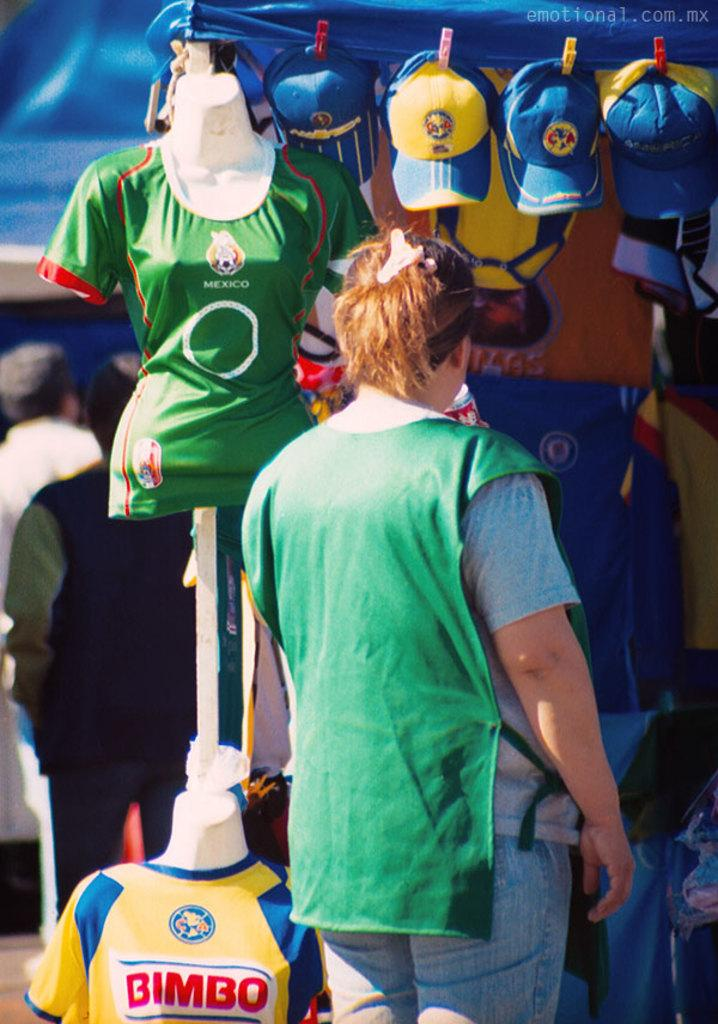<image>
Describe the image concisely. A woman is selling merchandise with Mexico written on it. 